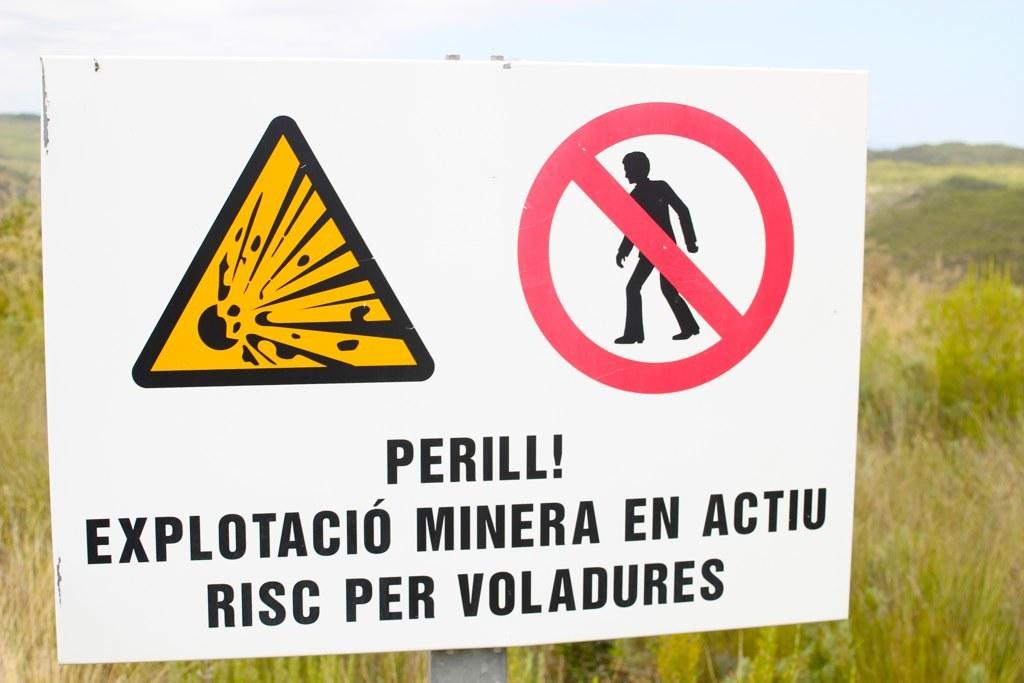<image>
Provide a brief description of the given image. A sign out in a field that says Perill! 